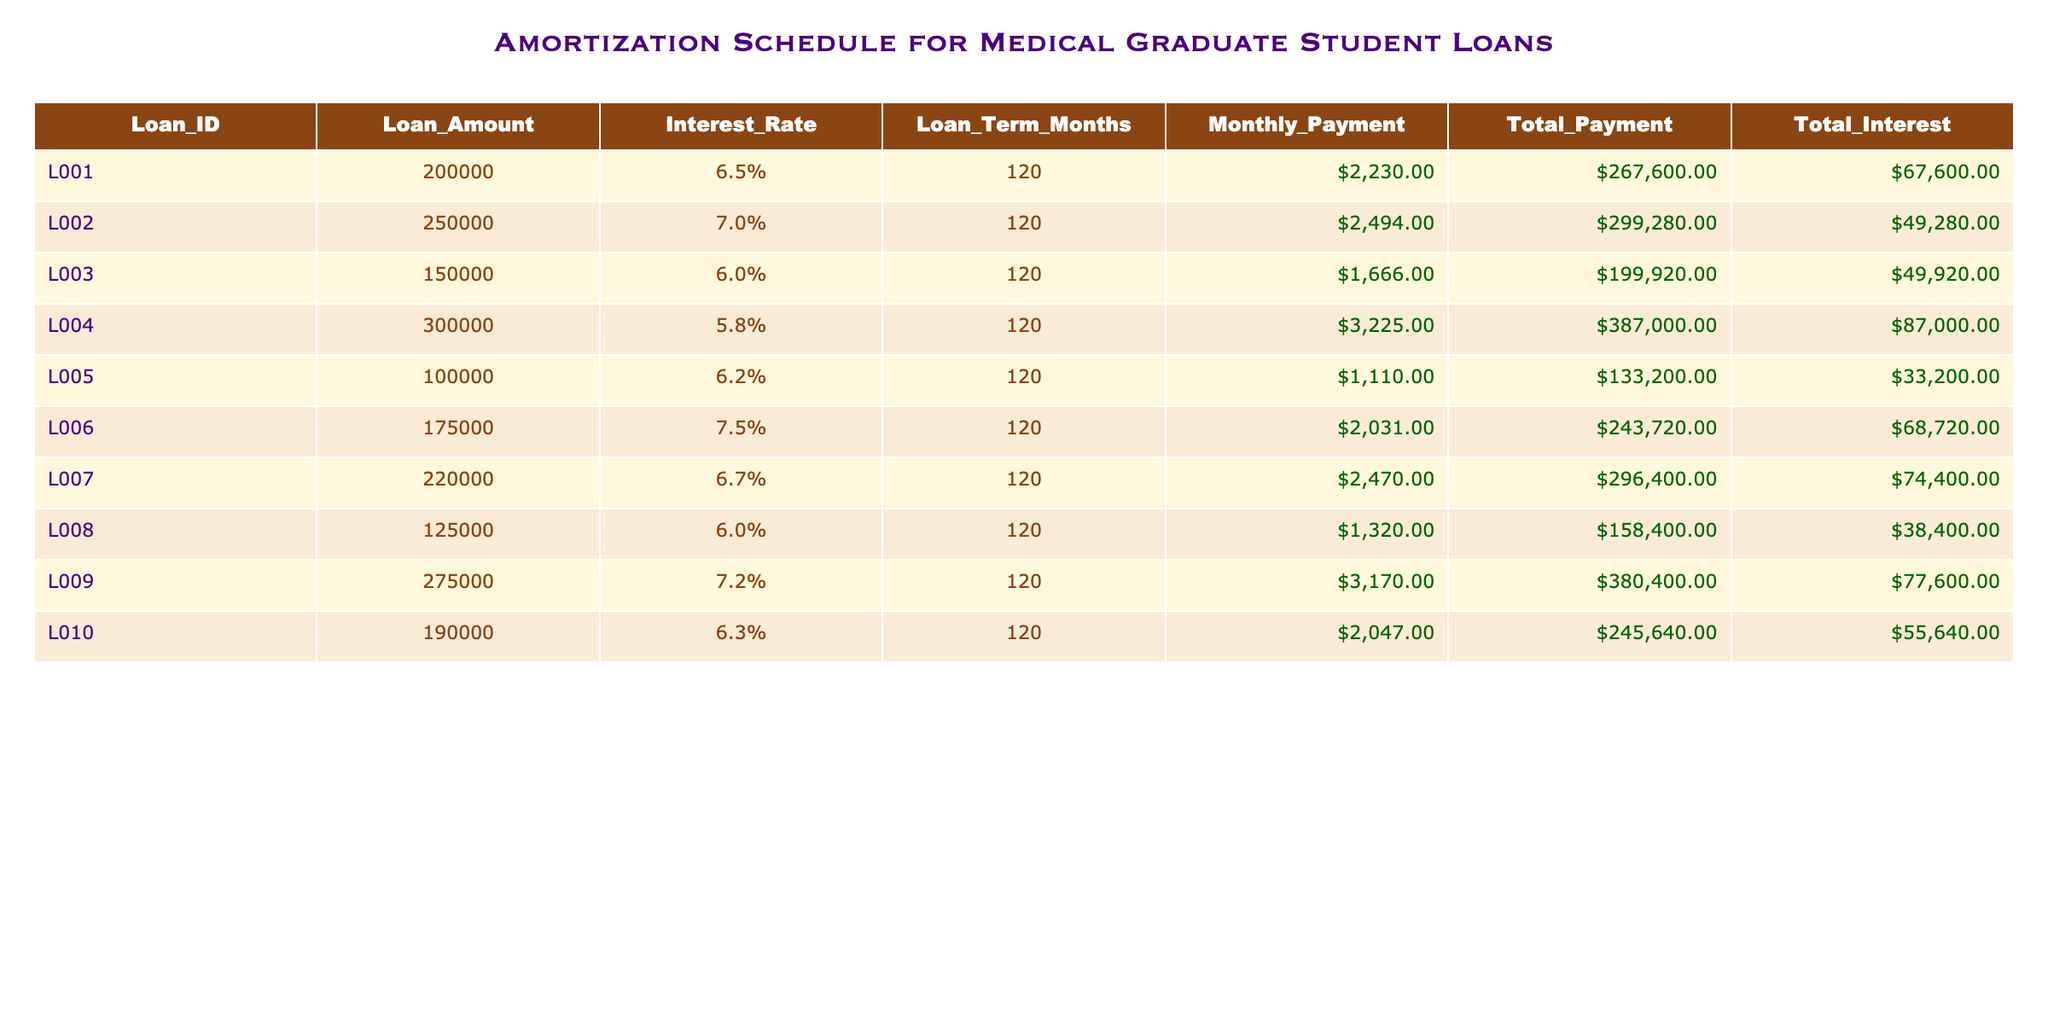What is the loan amount for Loan ID L006? The table shows that the loan amount for Loan ID L006 is listed under the column "Loan_Amount." Referring to that specific row, it indicates that the loan amount is 175000.
Answer: 175000 What is the total payment amount for Loan ID L009? By looking at the column "Total_Payment" in the row for Loan ID L009, it is indicated that the total payment amount is 380400.
Answer: 380400 Which loan has the highest total interest? To find the highest total interest, I will look at the "Total_Interest" column across all loans. After comparing the values, Loan ID L004 has the highest total interest of 87000.
Answer: 87000 What is the average monthly payment for all loans? First, I will sum the monthly payments across all loans (2230 + 2494 + 1666 + 3225 + 1110 + 2031 + 2470 + 1320 + 3170 + 2047 = 22163). There are 10 loans, so the average is 22163 / 10 = 2216.30.
Answer: 2216.30 Is the total payment for Loan ID L002 greater than 300000? Referring to the "Total_Payment" column for Loan ID L002, it shows 299280, which is less than 300000. Therefore, the statement is false.
Answer: No Which loan has the lowest interest rate and what is that rate? I will check the "Interest_Rate" column to find the lowest value. Comparing all rates, Loan ID L004 has the lowest interest rate of 5.8%.
Answer: 5.8% How much more is the total payment for Loan L009 compared to Loan L007? I will first find the total payment for both loans: Loan L009 has a total payment of 380400, and Loan L007 has a total payment of 296400. The difference calculated is 380400 - 296400 = 84000.
Answer: 84000 Does Loan ID L001 have a higher loan amount than Loan ID L008? By comparing the "Loan_Amount" for both loans, Loan ID L001 has 200000, while Loan ID L008 has 125000. Since 200000 is greater than 125000, the statement is true.
Answer: Yes What is the difference in total interest between Loan ID L002 and Loan ID L006? Looking at their total interest amounts, Loan ID L002 has 49280, and Loan ID L006 has 68720. The difference is 68720 - 49280 = 19440.
Answer: 19440 